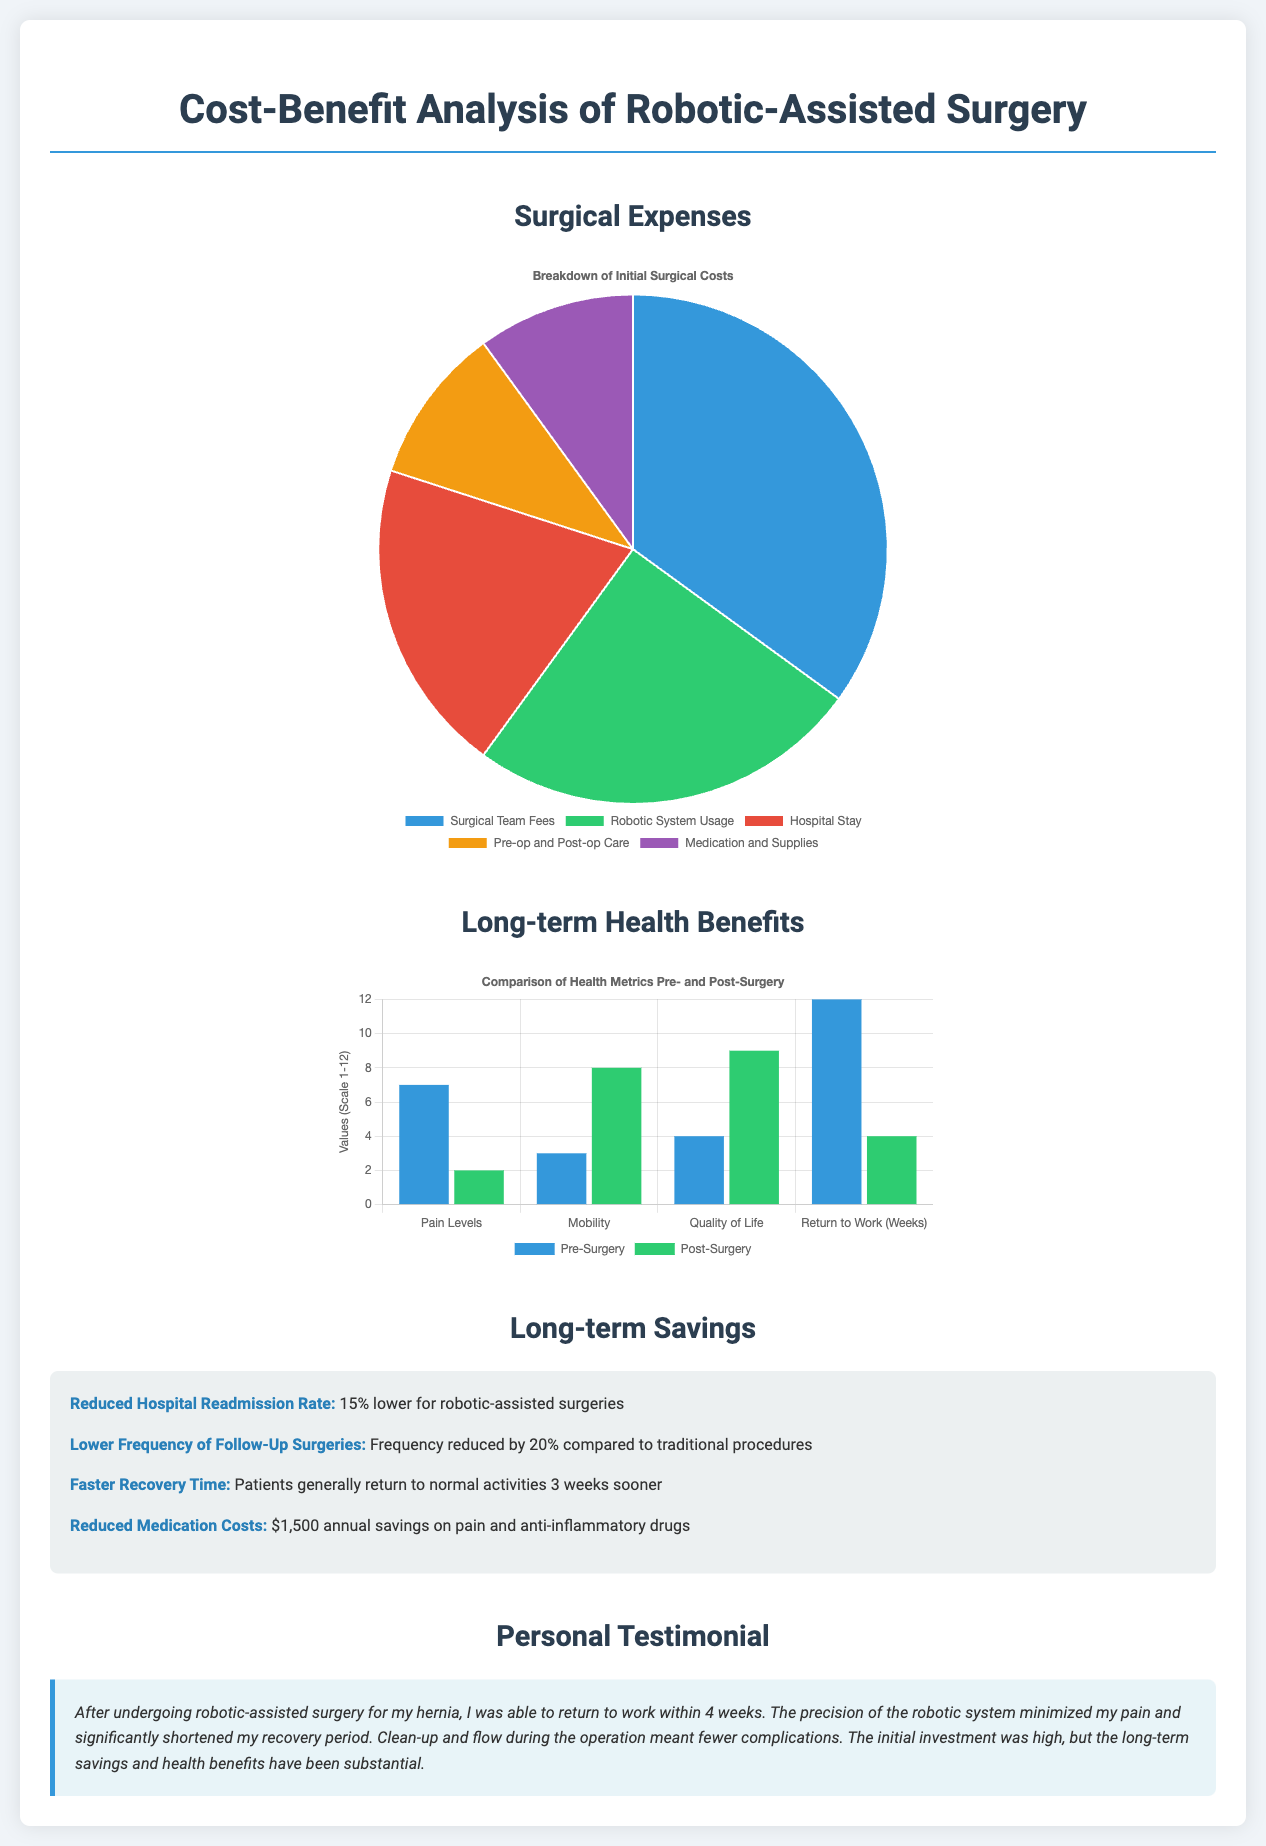What is the largest component of surgical expenses? The largest component of surgical expenses is indicated by the pie chart, which shows that Surgical Team Fees account for 35%.
Answer: Surgical Team Fees What percentage reduction in hospital readmissions is reported? The document states that there is a 15% reduction in hospital readmission rates for robotic-assisted surgeries.
Answer: 15% How many weeks sooner do patients generally return to normal activities after surgery? It is mentioned that patients return to normal activities 3 weeks sooner after surgery.
Answer: 3 weeks What was the pain level on a scale of 1-12 pre-surgery? The bar graph displays a pain level of 7 on a scale of 1-12 before surgery.
Answer: 7 What type of chart is used to show long-term health benefits? The document uses a bar graph to illustrate the comparison of health metrics pre- and post-surgery.
Answer: Bar graph What is the reported annual savings on medication costs after surgery? The document indicates an annual savings of $1,500 on pain and anti-inflammatory drugs.
Answer: $1,500 What was the average return to work period after surgery? According to the personal testimonial, the average return to work period was within 4 weeks after surgery.
Answer: 4 weeks What is the percentage reduction in frequency of follow-up surgeries? The document reports a reduction of 20% in the frequency of follow-up surgeries compared to traditional procedures.
Answer: 20% What is the primary coloring used for post-surgery in the benefits chart? The bar representing post-surgery is colored in green, which is represented as '#2ecc71' in the chart.
Answer: Green 